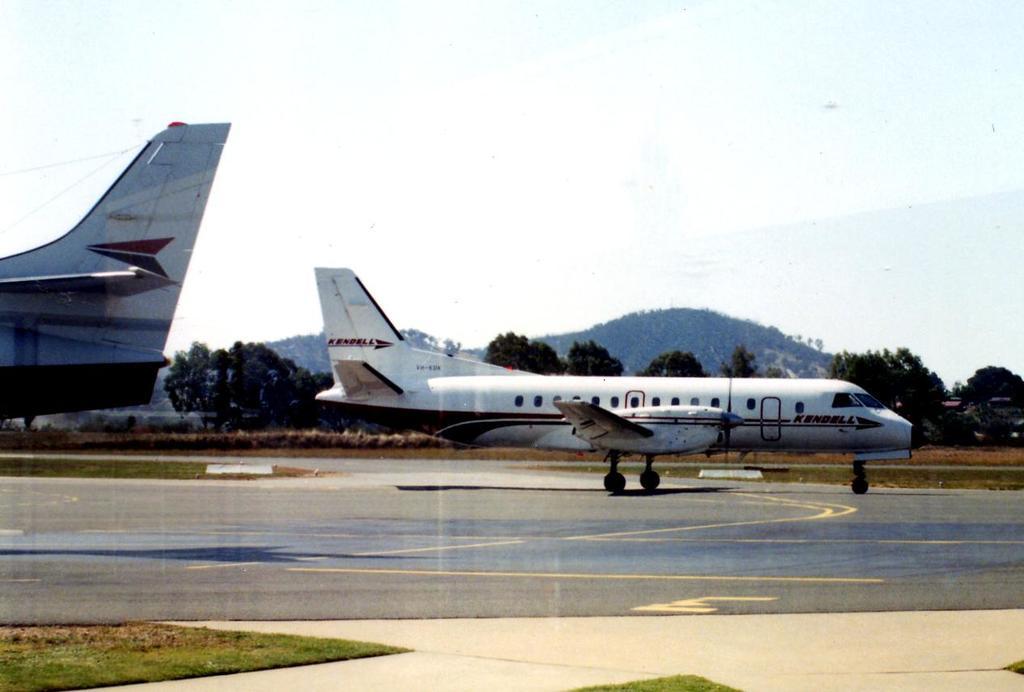Which airline is this?
Make the answer very short. Kendell. 